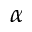<formula> <loc_0><loc_0><loc_500><loc_500>\alpha</formula> 